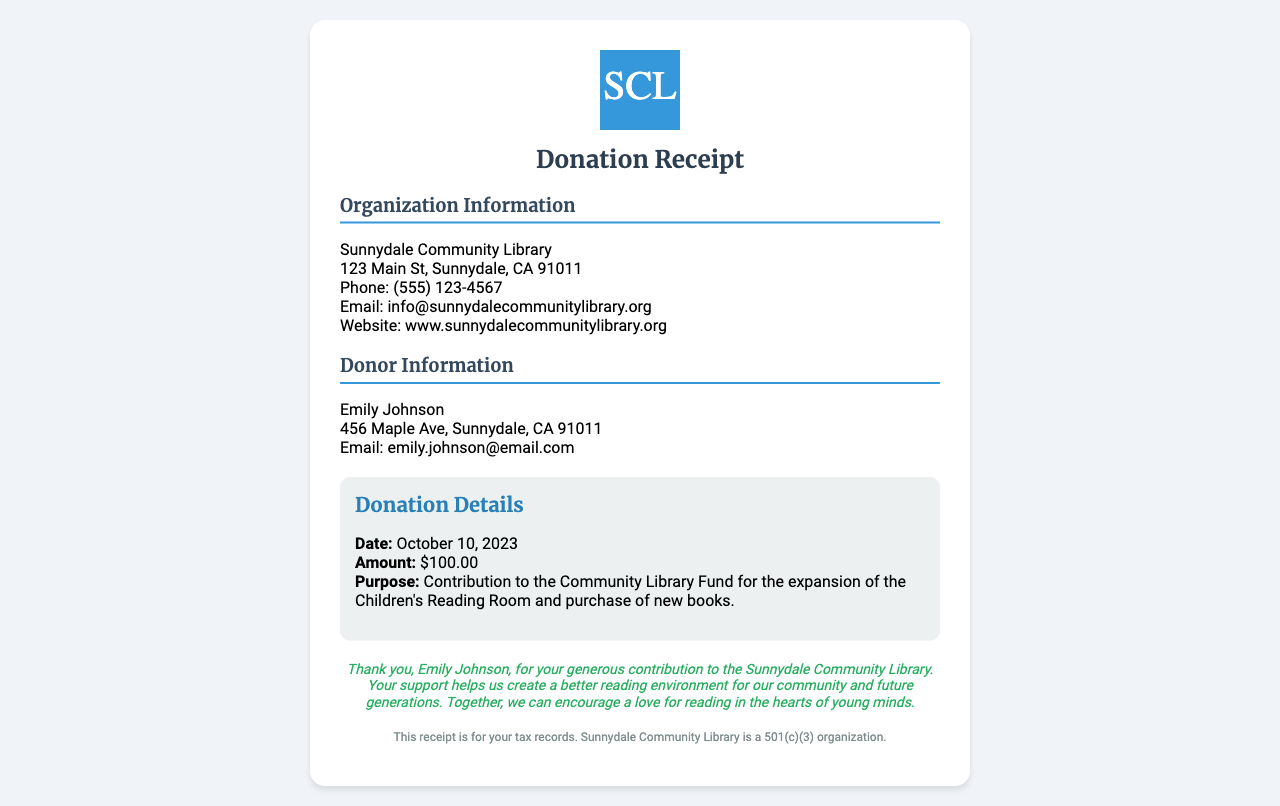What is the organization name? The organization's name is stated at the top of the document, prominently displayed as "Sunnydale Community Library."
Answer: Sunnydale Community Library Who is the donor? The document lists the donor's name in the donor information section as "Emily Johnson."
Answer: Emily Johnson What is the donation amount? The receipt specifies the donation amount in the donation details with the line "Amount: $100.00."
Answer: $100.00 What is the purpose of the donation? The purpose of the donation is detailed in the donation details section as "Contribution to the Community Library Fund for the expansion of the Children's Reading Room and purchase of new books."
Answer: Contribution to the Community Library Fund for the expansion of the Children's Reading Room and purchase of new books When was the donation made? The date of the donation is explicitly mentioned in the donation details section as "October 10, 2023."
Answer: October 10, 2023 What is the donor's email address? The donor's email address is provided in the donor information section, which states "Email: emily.johnson@email.com."
Answer: emily.johnson@email.com What is the purpose of the receipt? The purpose of the receipt is summarized at the bottom, implying that it is needed for tax records as it mentions "This receipt is for your tax records."
Answer: for your tax records What does the organization status indicate? The footer mentions that "Sunnydale Community Library is a 501(c)(3) organization," indicating its tax-exempt status.
Answer: 501(c)(3) organization What does the thank-you message emphasize? The thank-you message emphasizes the impact of the donor's contribution on the community, stating that it helps create a better reading environment.
Answer: create a better reading environment for our community and future generations 